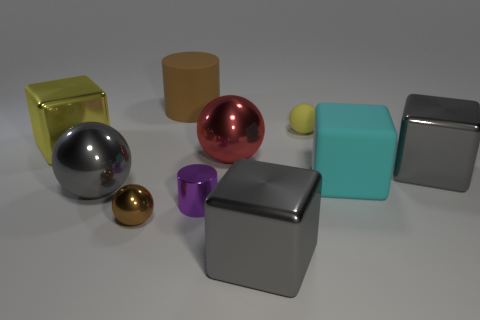Subtract all big gray metal balls. How many balls are left? 3 Subtract all yellow cylinders. How many gray blocks are left? 2 Subtract all red spheres. How many spheres are left? 3 Subtract 2 spheres. How many spheres are left? 2 Subtract all cubes. How many objects are left? 6 Subtract all brown blocks. Subtract all gray cylinders. How many blocks are left? 4 Subtract 0 green spheres. How many objects are left? 10 Subtract all big cyan rubber cubes. Subtract all large matte cylinders. How many objects are left? 8 Add 2 big gray spheres. How many big gray spheres are left? 3 Add 6 cyan matte things. How many cyan matte things exist? 7 